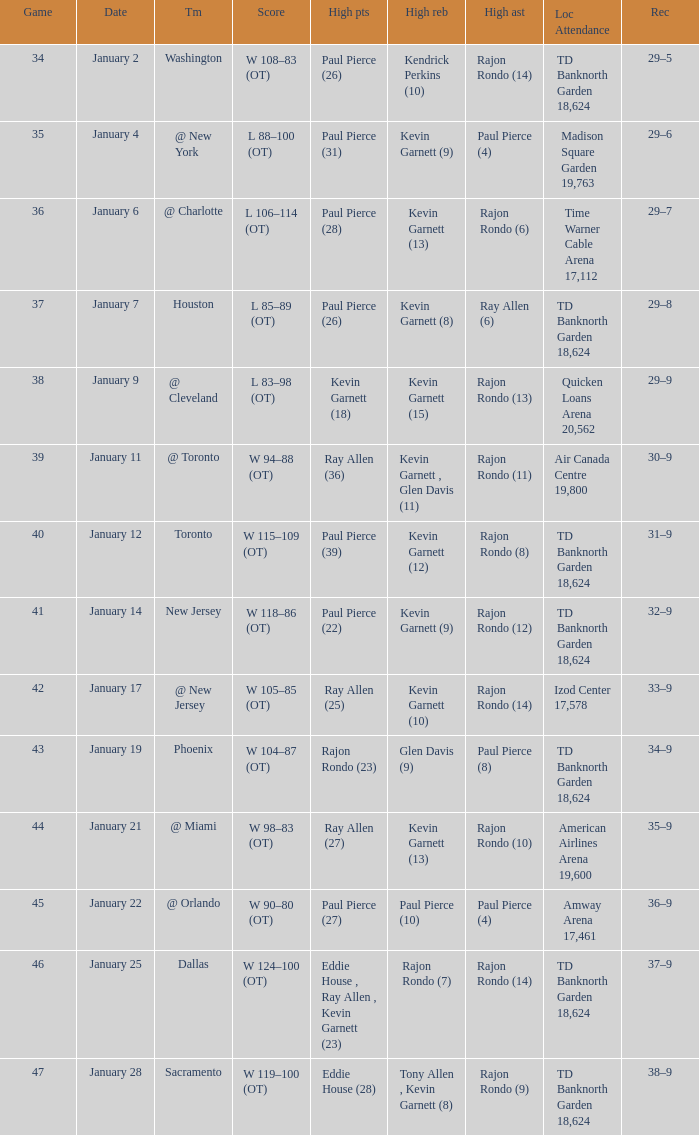Who had the high rebound total on january 6? Kevin Garnett (13). 